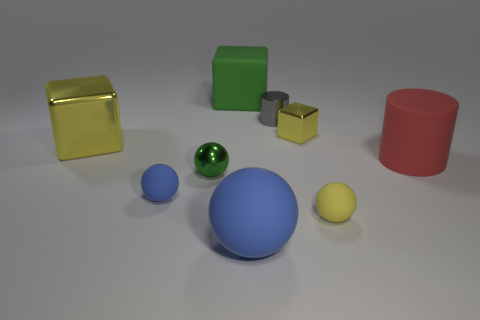Subtract 1 balls. How many balls are left? 3 Subtract all blue cubes. Subtract all gray spheres. How many cubes are left? 3 Subtract all cylinders. How many objects are left? 7 Add 7 big blue spheres. How many big blue spheres exist? 8 Subtract 1 green blocks. How many objects are left? 8 Subtract all tiny yellow metal things. Subtract all tiny green things. How many objects are left? 7 Add 8 blue rubber objects. How many blue rubber objects are left? 10 